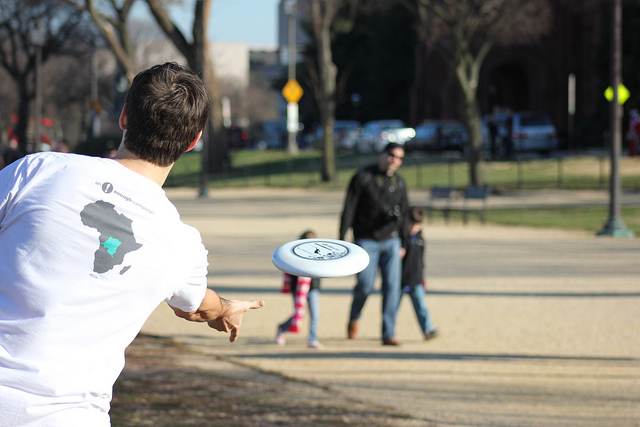How many cows are directly facing the camera? There are no cows to be seen, as the image depicts a person playing with a frisbee in a park-like setting, not a pastoral scene. 